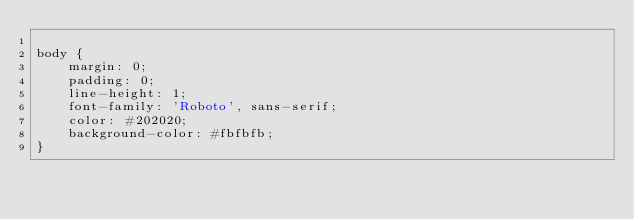Convert code to text. <code><loc_0><loc_0><loc_500><loc_500><_CSS_>
body {
    margin: 0;
    padding: 0;
    line-height: 1;
    font-family: 'Roboto', sans-serif;
    color: #202020;
    background-color: #fbfbfb;
}</code> 